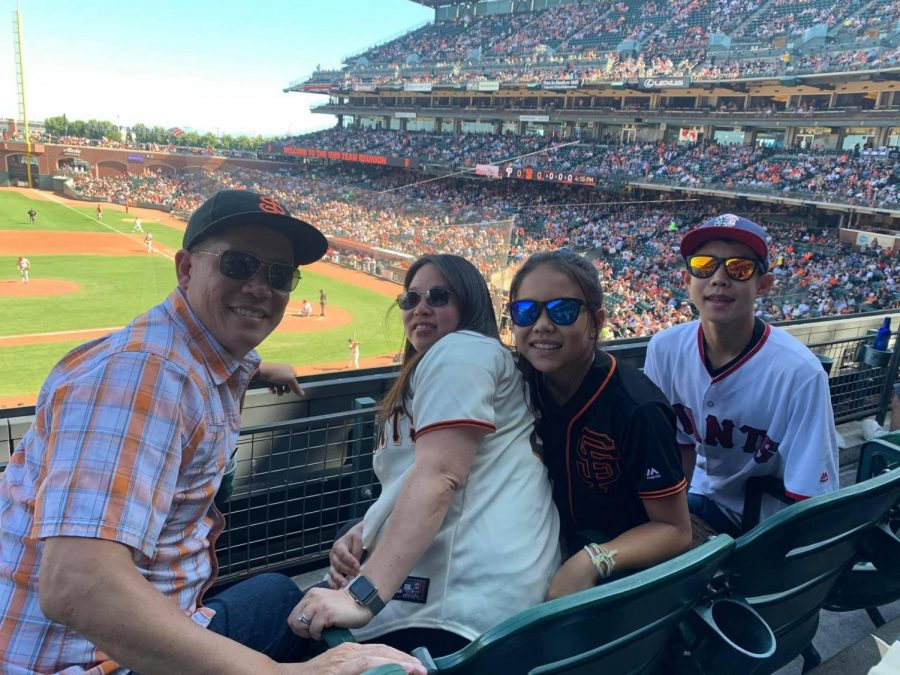Can you describe the atmosphere of the stadium considering the crowd and the game progress? The stadium appears to be quite lively and energetic. The stands are filled with enthusiastic fans, many dressed in team merchandise, indicating strong support for the home team. The scoreboard shows the game is progressing with a score of 0-0, suggesting a tight contest that keeps the crowd engaged and on edge. The bright, sunny weather further adds to the vibrant and joyous atmosphere, making it a perfect day for a baseball game. What could be some of the spectators' experiences during the game? Spectators are likely having a memorable experience. Those close to the field can enjoy a clear view of the players and the action. Families and friends might be sharing snacks, engaging in conversations, and capturing moments on their phones. The excitement of potential home runs or crucial outs would cause roars of applause and cheers. Additionally, the camaraderie among fans, the thrill of the game, and the overall warm, sunny day contribute to a pleasant and unforgettable outing at the ballpark. 